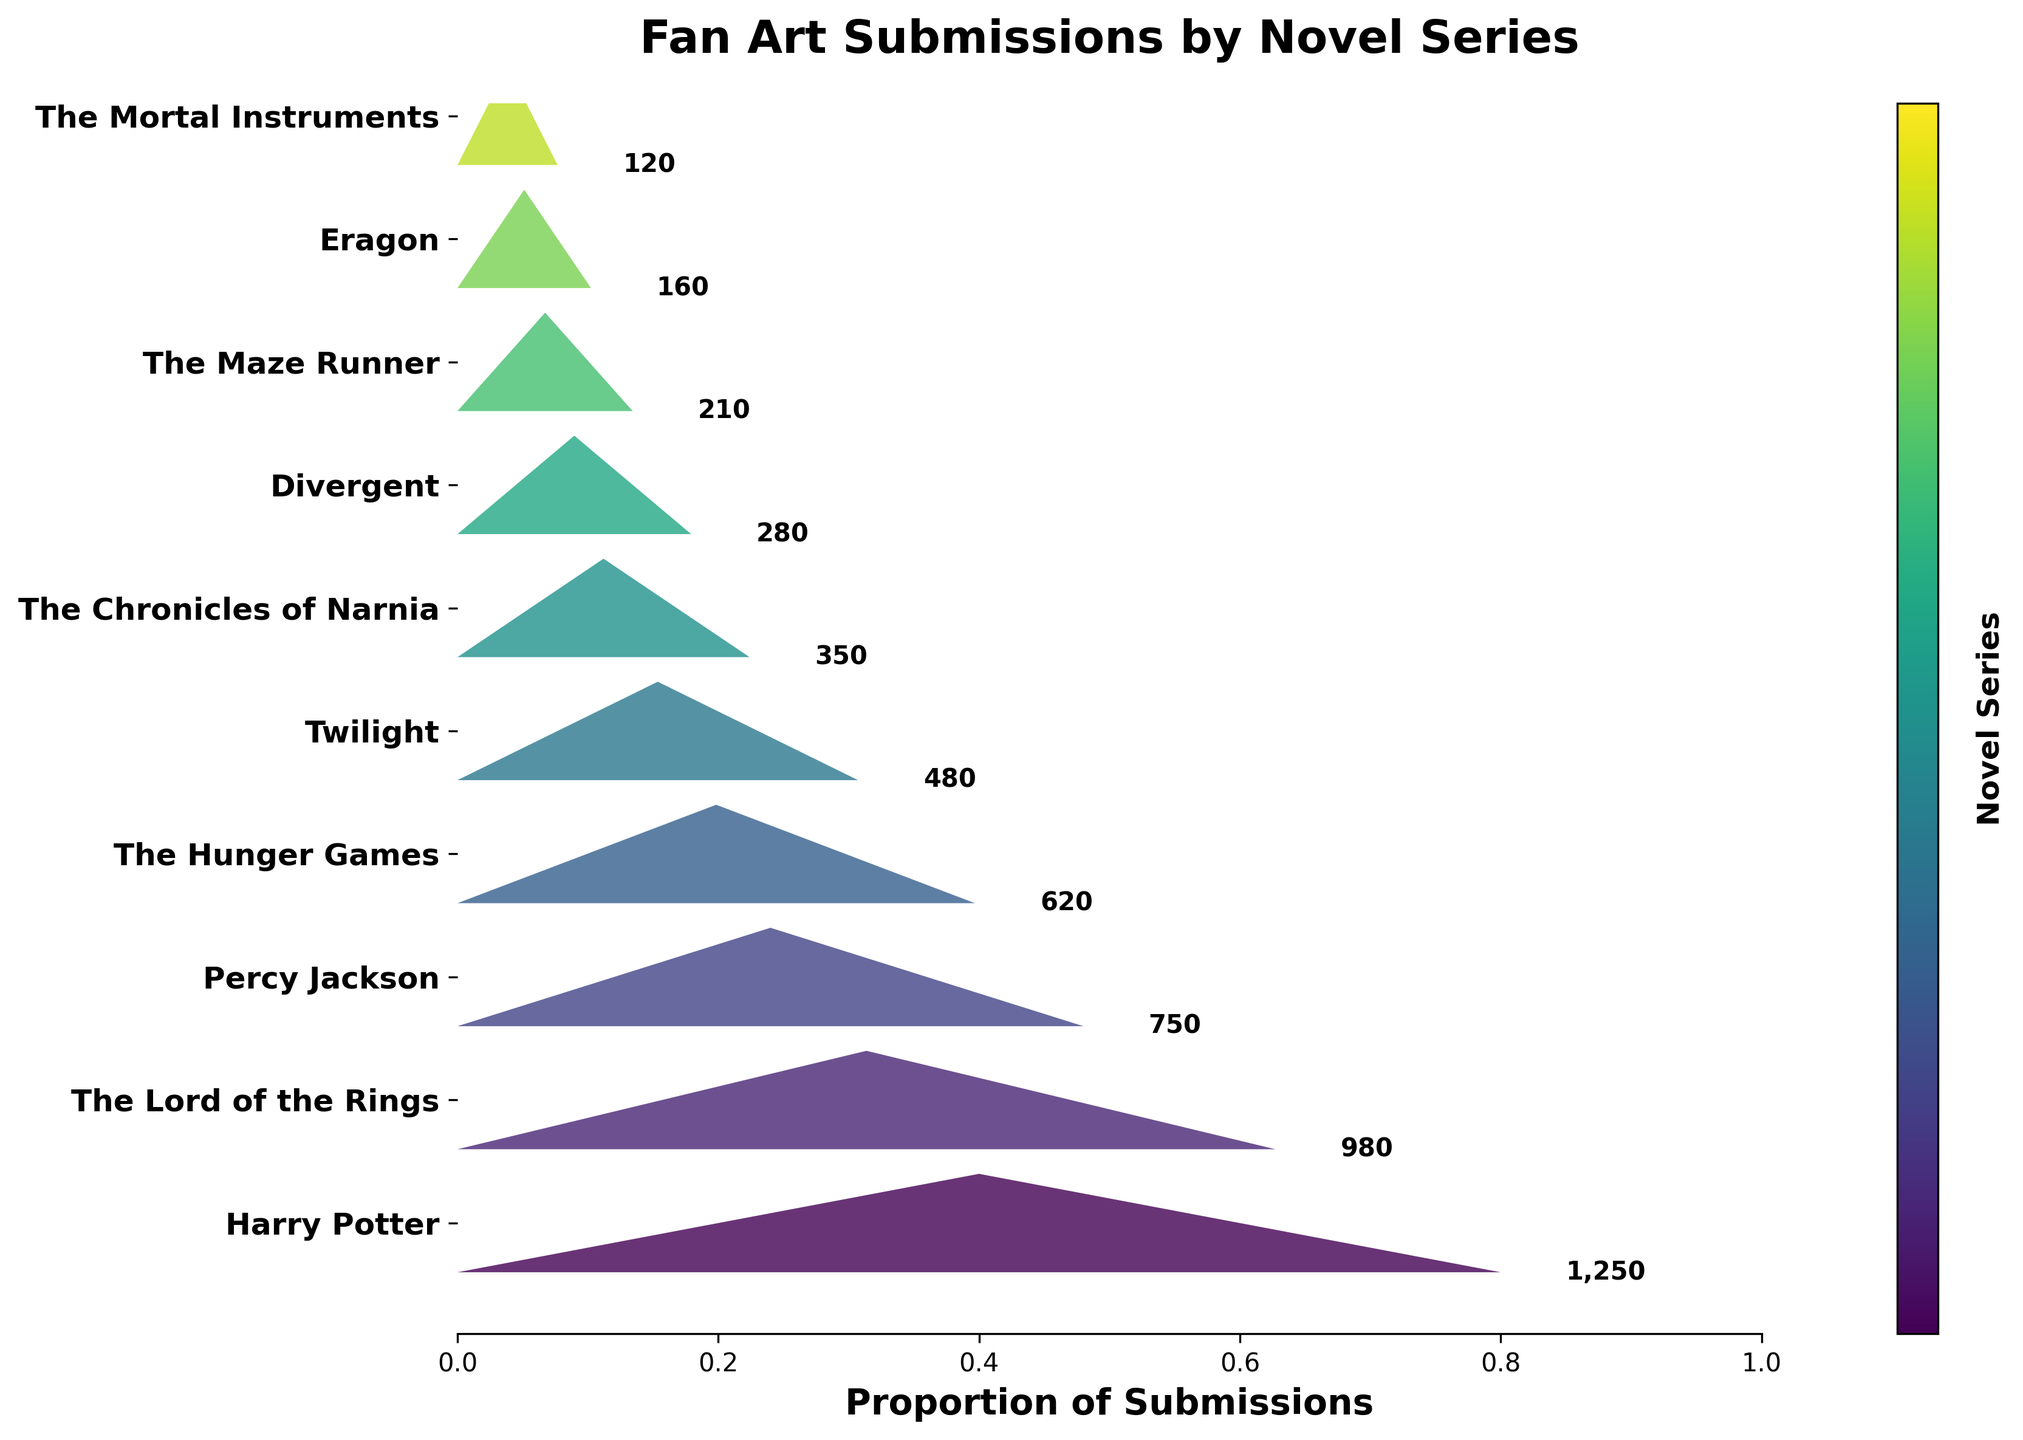What's the title of the figure? The title is displayed prominently at the top of the chart.
Answer: Fan Art Submissions by Novel Series Which novel series has the most fan art submissions? The funnel chart shows the largest segment at the top which corresponds to Harry Potter.
Answer: Harry Potter How many fan art submissions are there for The Hunger Games? Locate "The Hunger Games" on the y-axis and read the number next to it.
Answer: 620 What's the difference in fan art submissions between The Lord of the Rings and Twilight? Subtract the number of submissions for Twilight from the number of submissions for The Lord of the Rings (980 - 480).
Answer: 500 Which novel series has the least amount of fan art submissions? The smallest segment at the bottom of the funnel corresponds to The Mortal Instruments.
Answer: The Mortal Instruments What's the sum of the fan art submissions for the top three novel series? Add the submissions for Harry Potter, The Lord of the Rings, and Percy Jackson (1250 + 980 + 750).
Answer: 2,980 How many novel series have more than 500 fan art submissions? Count the novel series with submissions greater than 500: Harry Potter, The Lord of the Rings, Percy Jackson, and The Hunger Games (4 series).
Answer: 4 Which novel series has slightly more fan art submissions than Divergent? The series directly above Divergent on the chart has slightly more submissions, which is The Chronicles of Narnia.
Answer: The Chronicles of Narnia What's the average number of fan art submissions across all novel series? Divide the total number of submissions by the number of series (1250 + 980 + 750 + 620 + 480 + 350 + 280 + 210 + 160 + 120) / 10.
Answer: 520 Which novel series have a similar number of fan art submissions? The Maze Runner and Eragon have similar numbers of submissions, as their segments are close in size.
Answer: The Maze Runner and Eragon 